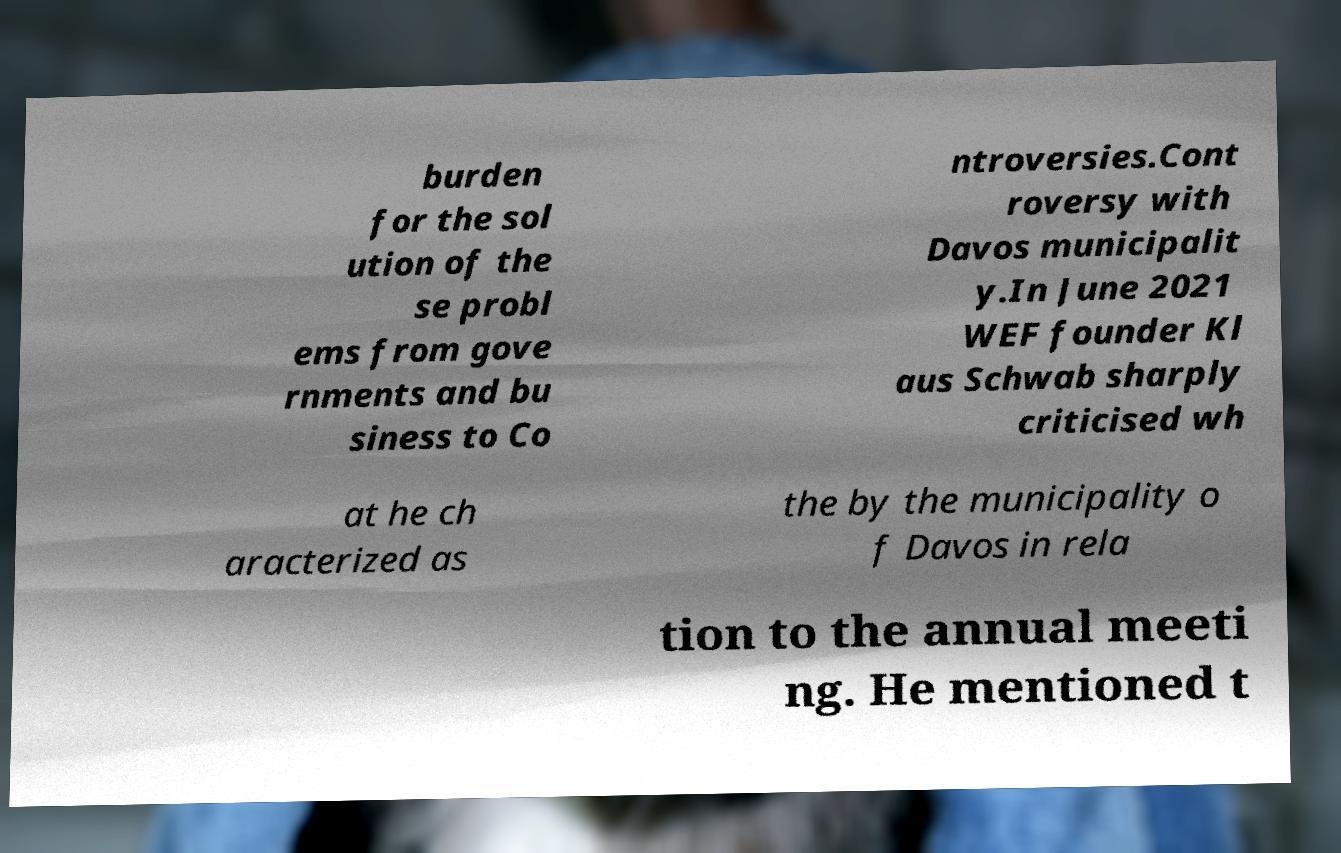There's text embedded in this image that I need extracted. Can you transcribe it verbatim? burden for the sol ution of the se probl ems from gove rnments and bu siness to Co ntroversies.Cont roversy with Davos municipalit y.In June 2021 WEF founder Kl aus Schwab sharply criticised wh at he ch aracterized as the by the municipality o f Davos in rela tion to the annual meeti ng. He mentioned t 